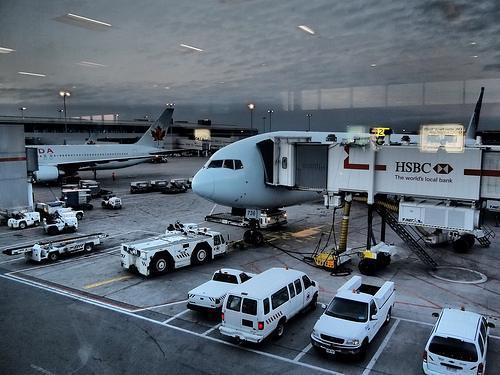How many airplanes are there?
Give a very brief answer. 2. How many automobiles are present?
Give a very brief answer. 4. 